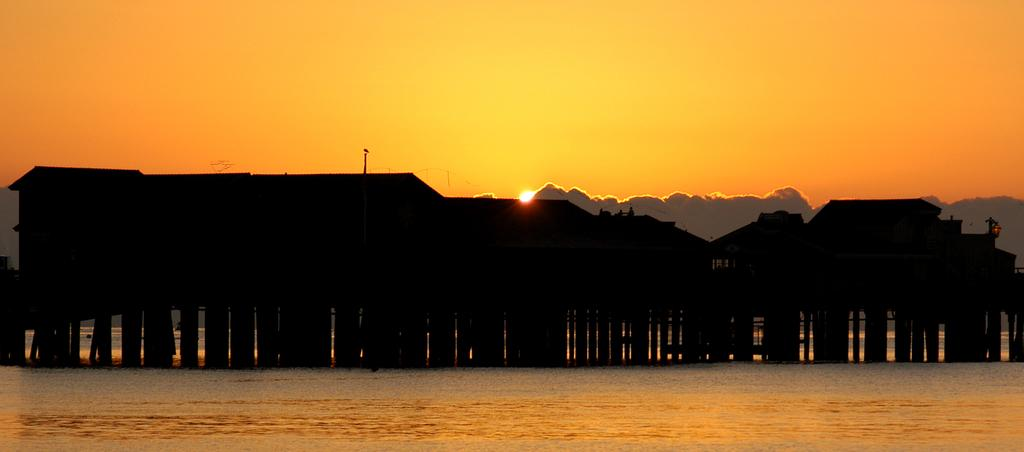What is the primary feature of the image? The primary feature of the image is a water surface. What can be seen in the vicinity of the water surface? There are houses between the water surface. How many carts are visible on the water surface in the image? There are no carts visible on the water surface in the image. What type of root can be seen growing from the water surface in the image? There are no roots visible on the water surface in the image. 